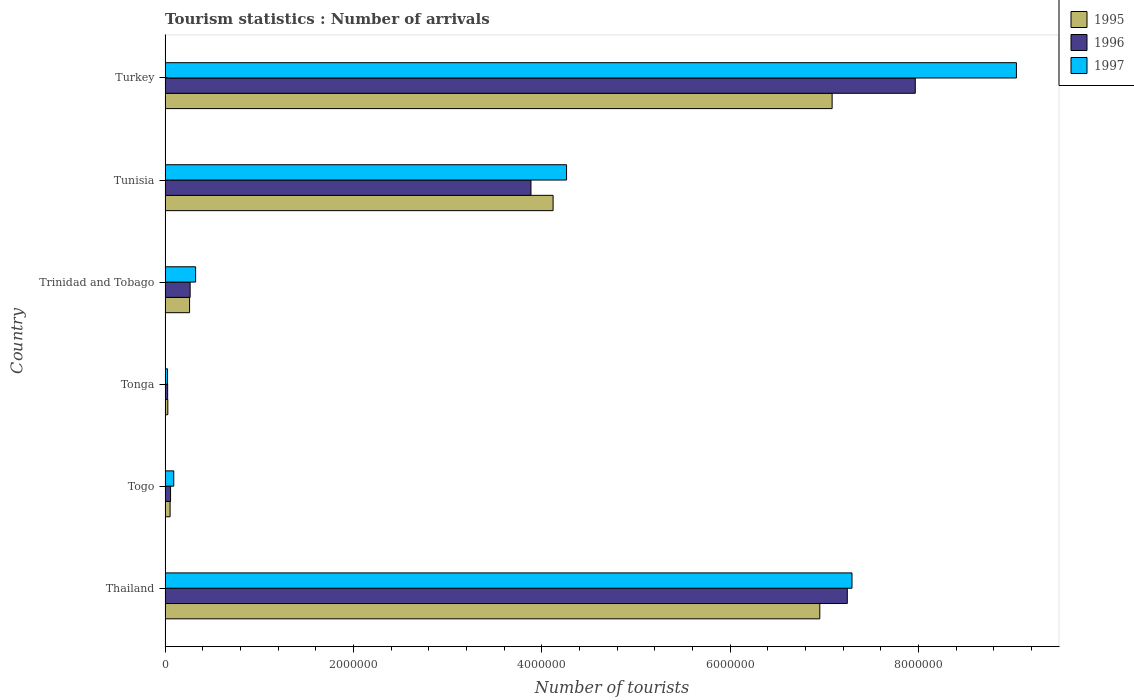Are the number of bars on each tick of the Y-axis equal?
Offer a terse response. Yes. What is the label of the 4th group of bars from the top?
Your answer should be compact. Tonga. What is the number of tourist arrivals in 1995 in Tunisia?
Make the answer very short. 4.12e+06. Across all countries, what is the maximum number of tourist arrivals in 1997?
Your answer should be compact. 9.04e+06. Across all countries, what is the minimum number of tourist arrivals in 1997?
Offer a very short reply. 2.60e+04. In which country was the number of tourist arrivals in 1997 maximum?
Provide a succinct answer. Turkey. In which country was the number of tourist arrivals in 1995 minimum?
Your response must be concise. Tonga. What is the total number of tourist arrivals in 1995 in the graph?
Offer a very short reply. 1.85e+07. What is the difference between the number of tourist arrivals in 1996 in Togo and that in Tonga?
Offer a very short reply. 3.10e+04. What is the difference between the number of tourist arrivals in 1995 in Tunisia and the number of tourist arrivals in 1996 in Trinidad and Tobago?
Your answer should be compact. 3.85e+06. What is the average number of tourist arrivals in 1997 per country?
Provide a short and direct response. 3.51e+06. What is the difference between the number of tourist arrivals in 1996 and number of tourist arrivals in 1995 in Trinidad and Tobago?
Offer a terse response. 6000. What is the ratio of the number of tourist arrivals in 1996 in Tonga to that in Trinidad and Tobago?
Make the answer very short. 0.1. Is the number of tourist arrivals in 1997 in Trinidad and Tobago less than that in Turkey?
Offer a very short reply. Yes. Is the difference between the number of tourist arrivals in 1996 in Thailand and Turkey greater than the difference between the number of tourist arrivals in 1995 in Thailand and Turkey?
Offer a terse response. No. What is the difference between the highest and the second highest number of tourist arrivals in 1995?
Your answer should be very brief. 1.31e+05. What is the difference between the highest and the lowest number of tourist arrivals in 1995?
Offer a very short reply. 7.05e+06. What does the 2nd bar from the top in Thailand represents?
Make the answer very short. 1996. Are all the bars in the graph horizontal?
Offer a terse response. Yes. How many countries are there in the graph?
Provide a short and direct response. 6. What is the difference between two consecutive major ticks on the X-axis?
Ensure brevity in your answer.  2.00e+06. Does the graph contain grids?
Your answer should be compact. No. What is the title of the graph?
Make the answer very short. Tourism statistics : Number of arrivals. Does "1965" appear as one of the legend labels in the graph?
Give a very brief answer. No. What is the label or title of the X-axis?
Offer a very short reply. Number of tourists. What is the Number of tourists in 1995 in Thailand?
Ensure brevity in your answer.  6.95e+06. What is the Number of tourists in 1996 in Thailand?
Keep it short and to the point. 7.24e+06. What is the Number of tourists in 1997 in Thailand?
Offer a terse response. 7.29e+06. What is the Number of tourists in 1995 in Togo?
Your answer should be very brief. 5.30e+04. What is the Number of tourists of 1996 in Togo?
Keep it short and to the point. 5.80e+04. What is the Number of tourists of 1997 in Togo?
Offer a very short reply. 9.20e+04. What is the Number of tourists in 1995 in Tonga?
Your answer should be very brief. 2.90e+04. What is the Number of tourists in 1996 in Tonga?
Provide a short and direct response. 2.70e+04. What is the Number of tourists of 1997 in Tonga?
Your response must be concise. 2.60e+04. What is the Number of tourists of 1996 in Trinidad and Tobago?
Provide a short and direct response. 2.66e+05. What is the Number of tourists of 1997 in Trinidad and Tobago?
Your response must be concise. 3.24e+05. What is the Number of tourists of 1995 in Tunisia?
Provide a short and direct response. 4.12e+06. What is the Number of tourists in 1996 in Tunisia?
Provide a short and direct response. 3.88e+06. What is the Number of tourists of 1997 in Tunisia?
Ensure brevity in your answer.  4.26e+06. What is the Number of tourists of 1995 in Turkey?
Ensure brevity in your answer.  7.08e+06. What is the Number of tourists in 1996 in Turkey?
Make the answer very short. 7.97e+06. What is the Number of tourists in 1997 in Turkey?
Offer a very short reply. 9.04e+06. Across all countries, what is the maximum Number of tourists in 1995?
Provide a short and direct response. 7.08e+06. Across all countries, what is the maximum Number of tourists in 1996?
Give a very brief answer. 7.97e+06. Across all countries, what is the maximum Number of tourists in 1997?
Provide a short and direct response. 9.04e+06. Across all countries, what is the minimum Number of tourists in 1995?
Your answer should be very brief. 2.90e+04. Across all countries, what is the minimum Number of tourists in 1996?
Your answer should be very brief. 2.70e+04. Across all countries, what is the minimum Number of tourists of 1997?
Offer a very short reply. 2.60e+04. What is the total Number of tourists in 1995 in the graph?
Keep it short and to the point. 1.85e+07. What is the total Number of tourists of 1996 in the graph?
Make the answer very short. 1.94e+07. What is the total Number of tourists of 1997 in the graph?
Keep it short and to the point. 2.10e+07. What is the difference between the Number of tourists of 1995 in Thailand and that in Togo?
Make the answer very short. 6.90e+06. What is the difference between the Number of tourists in 1996 in Thailand and that in Togo?
Offer a terse response. 7.19e+06. What is the difference between the Number of tourists of 1997 in Thailand and that in Togo?
Your answer should be compact. 7.20e+06. What is the difference between the Number of tourists in 1995 in Thailand and that in Tonga?
Offer a very short reply. 6.92e+06. What is the difference between the Number of tourists of 1996 in Thailand and that in Tonga?
Your answer should be very brief. 7.22e+06. What is the difference between the Number of tourists in 1997 in Thailand and that in Tonga?
Provide a short and direct response. 7.27e+06. What is the difference between the Number of tourists in 1995 in Thailand and that in Trinidad and Tobago?
Ensure brevity in your answer.  6.69e+06. What is the difference between the Number of tourists of 1996 in Thailand and that in Trinidad and Tobago?
Provide a short and direct response. 6.98e+06. What is the difference between the Number of tourists of 1997 in Thailand and that in Trinidad and Tobago?
Offer a terse response. 6.97e+06. What is the difference between the Number of tourists of 1995 in Thailand and that in Tunisia?
Offer a terse response. 2.83e+06. What is the difference between the Number of tourists in 1996 in Thailand and that in Tunisia?
Provide a succinct answer. 3.36e+06. What is the difference between the Number of tourists in 1997 in Thailand and that in Tunisia?
Provide a succinct answer. 3.03e+06. What is the difference between the Number of tourists of 1995 in Thailand and that in Turkey?
Ensure brevity in your answer.  -1.31e+05. What is the difference between the Number of tourists of 1996 in Thailand and that in Turkey?
Give a very brief answer. -7.22e+05. What is the difference between the Number of tourists of 1997 in Thailand and that in Turkey?
Offer a very short reply. -1.75e+06. What is the difference between the Number of tourists in 1995 in Togo and that in Tonga?
Offer a very short reply. 2.40e+04. What is the difference between the Number of tourists of 1996 in Togo and that in Tonga?
Keep it short and to the point. 3.10e+04. What is the difference between the Number of tourists in 1997 in Togo and that in Tonga?
Offer a very short reply. 6.60e+04. What is the difference between the Number of tourists of 1995 in Togo and that in Trinidad and Tobago?
Your response must be concise. -2.07e+05. What is the difference between the Number of tourists of 1996 in Togo and that in Trinidad and Tobago?
Your response must be concise. -2.08e+05. What is the difference between the Number of tourists in 1997 in Togo and that in Trinidad and Tobago?
Ensure brevity in your answer.  -2.32e+05. What is the difference between the Number of tourists of 1995 in Togo and that in Tunisia?
Your response must be concise. -4.07e+06. What is the difference between the Number of tourists of 1996 in Togo and that in Tunisia?
Keep it short and to the point. -3.83e+06. What is the difference between the Number of tourists in 1997 in Togo and that in Tunisia?
Make the answer very short. -4.17e+06. What is the difference between the Number of tourists in 1995 in Togo and that in Turkey?
Your response must be concise. -7.03e+06. What is the difference between the Number of tourists in 1996 in Togo and that in Turkey?
Provide a short and direct response. -7.91e+06. What is the difference between the Number of tourists of 1997 in Togo and that in Turkey?
Provide a short and direct response. -8.95e+06. What is the difference between the Number of tourists of 1995 in Tonga and that in Trinidad and Tobago?
Keep it short and to the point. -2.31e+05. What is the difference between the Number of tourists of 1996 in Tonga and that in Trinidad and Tobago?
Offer a terse response. -2.39e+05. What is the difference between the Number of tourists in 1997 in Tonga and that in Trinidad and Tobago?
Keep it short and to the point. -2.98e+05. What is the difference between the Number of tourists of 1995 in Tonga and that in Tunisia?
Your response must be concise. -4.09e+06. What is the difference between the Number of tourists of 1996 in Tonga and that in Tunisia?
Make the answer very short. -3.86e+06. What is the difference between the Number of tourists of 1997 in Tonga and that in Tunisia?
Offer a terse response. -4.24e+06. What is the difference between the Number of tourists of 1995 in Tonga and that in Turkey?
Your answer should be very brief. -7.05e+06. What is the difference between the Number of tourists of 1996 in Tonga and that in Turkey?
Give a very brief answer. -7.94e+06. What is the difference between the Number of tourists of 1997 in Tonga and that in Turkey?
Give a very brief answer. -9.01e+06. What is the difference between the Number of tourists of 1995 in Trinidad and Tobago and that in Tunisia?
Provide a short and direct response. -3.86e+06. What is the difference between the Number of tourists in 1996 in Trinidad and Tobago and that in Tunisia?
Provide a succinct answer. -3.62e+06. What is the difference between the Number of tourists of 1997 in Trinidad and Tobago and that in Tunisia?
Give a very brief answer. -3.94e+06. What is the difference between the Number of tourists of 1995 in Trinidad and Tobago and that in Turkey?
Your answer should be very brief. -6.82e+06. What is the difference between the Number of tourists in 1996 in Trinidad and Tobago and that in Turkey?
Your response must be concise. -7.70e+06. What is the difference between the Number of tourists of 1997 in Trinidad and Tobago and that in Turkey?
Give a very brief answer. -8.72e+06. What is the difference between the Number of tourists in 1995 in Tunisia and that in Turkey?
Your answer should be compact. -2.96e+06. What is the difference between the Number of tourists in 1996 in Tunisia and that in Turkey?
Make the answer very short. -4.08e+06. What is the difference between the Number of tourists of 1997 in Tunisia and that in Turkey?
Give a very brief answer. -4.78e+06. What is the difference between the Number of tourists of 1995 in Thailand and the Number of tourists of 1996 in Togo?
Give a very brief answer. 6.89e+06. What is the difference between the Number of tourists in 1995 in Thailand and the Number of tourists in 1997 in Togo?
Your answer should be very brief. 6.86e+06. What is the difference between the Number of tourists in 1996 in Thailand and the Number of tourists in 1997 in Togo?
Ensure brevity in your answer.  7.15e+06. What is the difference between the Number of tourists of 1995 in Thailand and the Number of tourists of 1996 in Tonga?
Your answer should be compact. 6.92e+06. What is the difference between the Number of tourists of 1995 in Thailand and the Number of tourists of 1997 in Tonga?
Your answer should be very brief. 6.93e+06. What is the difference between the Number of tourists of 1996 in Thailand and the Number of tourists of 1997 in Tonga?
Your response must be concise. 7.22e+06. What is the difference between the Number of tourists in 1995 in Thailand and the Number of tourists in 1996 in Trinidad and Tobago?
Ensure brevity in your answer.  6.69e+06. What is the difference between the Number of tourists in 1995 in Thailand and the Number of tourists in 1997 in Trinidad and Tobago?
Provide a short and direct response. 6.63e+06. What is the difference between the Number of tourists of 1996 in Thailand and the Number of tourists of 1997 in Trinidad and Tobago?
Make the answer very short. 6.92e+06. What is the difference between the Number of tourists of 1995 in Thailand and the Number of tourists of 1996 in Tunisia?
Your answer should be very brief. 3.07e+06. What is the difference between the Number of tourists of 1995 in Thailand and the Number of tourists of 1997 in Tunisia?
Give a very brief answer. 2.69e+06. What is the difference between the Number of tourists in 1996 in Thailand and the Number of tourists in 1997 in Tunisia?
Offer a very short reply. 2.98e+06. What is the difference between the Number of tourists in 1995 in Thailand and the Number of tourists in 1996 in Turkey?
Give a very brief answer. -1.01e+06. What is the difference between the Number of tourists of 1995 in Thailand and the Number of tourists of 1997 in Turkey?
Your answer should be very brief. -2.09e+06. What is the difference between the Number of tourists in 1996 in Thailand and the Number of tourists in 1997 in Turkey?
Offer a very short reply. -1.80e+06. What is the difference between the Number of tourists in 1995 in Togo and the Number of tourists in 1996 in Tonga?
Your answer should be very brief. 2.60e+04. What is the difference between the Number of tourists of 1995 in Togo and the Number of tourists of 1997 in Tonga?
Keep it short and to the point. 2.70e+04. What is the difference between the Number of tourists of 1996 in Togo and the Number of tourists of 1997 in Tonga?
Your response must be concise. 3.20e+04. What is the difference between the Number of tourists of 1995 in Togo and the Number of tourists of 1996 in Trinidad and Tobago?
Give a very brief answer. -2.13e+05. What is the difference between the Number of tourists of 1995 in Togo and the Number of tourists of 1997 in Trinidad and Tobago?
Keep it short and to the point. -2.71e+05. What is the difference between the Number of tourists of 1996 in Togo and the Number of tourists of 1997 in Trinidad and Tobago?
Your answer should be very brief. -2.66e+05. What is the difference between the Number of tourists in 1995 in Togo and the Number of tourists in 1996 in Tunisia?
Your response must be concise. -3.83e+06. What is the difference between the Number of tourists of 1995 in Togo and the Number of tourists of 1997 in Tunisia?
Give a very brief answer. -4.21e+06. What is the difference between the Number of tourists of 1996 in Togo and the Number of tourists of 1997 in Tunisia?
Provide a succinct answer. -4.20e+06. What is the difference between the Number of tourists in 1995 in Togo and the Number of tourists in 1996 in Turkey?
Offer a very short reply. -7.91e+06. What is the difference between the Number of tourists in 1995 in Togo and the Number of tourists in 1997 in Turkey?
Your answer should be compact. -8.99e+06. What is the difference between the Number of tourists in 1996 in Togo and the Number of tourists in 1997 in Turkey?
Offer a terse response. -8.98e+06. What is the difference between the Number of tourists in 1995 in Tonga and the Number of tourists in 1996 in Trinidad and Tobago?
Your response must be concise. -2.37e+05. What is the difference between the Number of tourists in 1995 in Tonga and the Number of tourists in 1997 in Trinidad and Tobago?
Your response must be concise. -2.95e+05. What is the difference between the Number of tourists of 1996 in Tonga and the Number of tourists of 1997 in Trinidad and Tobago?
Give a very brief answer. -2.97e+05. What is the difference between the Number of tourists of 1995 in Tonga and the Number of tourists of 1996 in Tunisia?
Your answer should be very brief. -3.86e+06. What is the difference between the Number of tourists in 1995 in Tonga and the Number of tourists in 1997 in Tunisia?
Keep it short and to the point. -4.23e+06. What is the difference between the Number of tourists in 1996 in Tonga and the Number of tourists in 1997 in Tunisia?
Make the answer very short. -4.24e+06. What is the difference between the Number of tourists of 1995 in Tonga and the Number of tourists of 1996 in Turkey?
Your response must be concise. -7.94e+06. What is the difference between the Number of tourists in 1995 in Tonga and the Number of tourists in 1997 in Turkey?
Give a very brief answer. -9.01e+06. What is the difference between the Number of tourists of 1996 in Tonga and the Number of tourists of 1997 in Turkey?
Keep it short and to the point. -9.01e+06. What is the difference between the Number of tourists in 1995 in Trinidad and Tobago and the Number of tourists in 1996 in Tunisia?
Provide a short and direct response. -3.62e+06. What is the difference between the Number of tourists of 1995 in Trinidad and Tobago and the Number of tourists of 1997 in Tunisia?
Keep it short and to the point. -4.00e+06. What is the difference between the Number of tourists of 1996 in Trinidad and Tobago and the Number of tourists of 1997 in Tunisia?
Provide a succinct answer. -4.00e+06. What is the difference between the Number of tourists of 1995 in Trinidad and Tobago and the Number of tourists of 1996 in Turkey?
Give a very brief answer. -7.71e+06. What is the difference between the Number of tourists in 1995 in Trinidad and Tobago and the Number of tourists in 1997 in Turkey?
Provide a short and direct response. -8.78e+06. What is the difference between the Number of tourists of 1996 in Trinidad and Tobago and the Number of tourists of 1997 in Turkey?
Ensure brevity in your answer.  -8.77e+06. What is the difference between the Number of tourists in 1995 in Tunisia and the Number of tourists in 1996 in Turkey?
Your answer should be compact. -3.85e+06. What is the difference between the Number of tourists in 1995 in Tunisia and the Number of tourists in 1997 in Turkey?
Provide a succinct answer. -4.92e+06. What is the difference between the Number of tourists in 1996 in Tunisia and the Number of tourists in 1997 in Turkey?
Give a very brief answer. -5.16e+06. What is the average Number of tourists in 1995 per country?
Ensure brevity in your answer.  3.08e+06. What is the average Number of tourists of 1996 per country?
Keep it short and to the point. 3.24e+06. What is the average Number of tourists of 1997 per country?
Keep it short and to the point. 3.51e+06. What is the difference between the Number of tourists of 1995 and Number of tourists of 1996 in Thailand?
Your response must be concise. -2.92e+05. What is the difference between the Number of tourists of 1995 and Number of tourists of 1997 in Thailand?
Make the answer very short. -3.42e+05. What is the difference between the Number of tourists of 1995 and Number of tourists of 1996 in Togo?
Your answer should be very brief. -5000. What is the difference between the Number of tourists of 1995 and Number of tourists of 1997 in Togo?
Your response must be concise. -3.90e+04. What is the difference between the Number of tourists of 1996 and Number of tourists of 1997 in Togo?
Offer a very short reply. -3.40e+04. What is the difference between the Number of tourists of 1995 and Number of tourists of 1996 in Tonga?
Give a very brief answer. 2000. What is the difference between the Number of tourists in 1995 and Number of tourists in 1997 in Tonga?
Keep it short and to the point. 3000. What is the difference between the Number of tourists of 1995 and Number of tourists of 1996 in Trinidad and Tobago?
Provide a short and direct response. -6000. What is the difference between the Number of tourists of 1995 and Number of tourists of 1997 in Trinidad and Tobago?
Give a very brief answer. -6.40e+04. What is the difference between the Number of tourists of 1996 and Number of tourists of 1997 in Trinidad and Tobago?
Offer a very short reply. -5.80e+04. What is the difference between the Number of tourists of 1995 and Number of tourists of 1996 in Tunisia?
Ensure brevity in your answer.  2.35e+05. What is the difference between the Number of tourists of 1995 and Number of tourists of 1997 in Tunisia?
Offer a very short reply. -1.43e+05. What is the difference between the Number of tourists in 1996 and Number of tourists in 1997 in Tunisia?
Make the answer very short. -3.78e+05. What is the difference between the Number of tourists in 1995 and Number of tourists in 1996 in Turkey?
Offer a terse response. -8.83e+05. What is the difference between the Number of tourists of 1995 and Number of tourists of 1997 in Turkey?
Ensure brevity in your answer.  -1.96e+06. What is the difference between the Number of tourists in 1996 and Number of tourists in 1997 in Turkey?
Provide a short and direct response. -1.07e+06. What is the ratio of the Number of tourists in 1995 in Thailand to that in Togo?
Make the answer very short. 131.17. What is the ratio of the Number of tourists of 1996 in Thailand to that in Togo?
Provide a short and direct response. 124.9. What is the ratio of the Number of tourists of 1997 in Thailand to that in Togo?
Provide a short and direct response. 79.28. What is the ratio of the Number of tourists of 1995 in Thailand to that in Tonga?
Provide a short and direct response. 239.72. What is the ratio of the Number of tourists in 1996 in Thailand to that in Tonga?
Make the answer very short. 268.3. What is the ratio of the Number of tourists of 1997 in Thailand to that in Tonga?
Ensure brevity in your answer.  280.54. What is the ratio of the Number of tourists of 1995 in Thailand to that in Trinidad and Tobago?
Offer a terse response. 26.74. What is the ratio of the Number of tourists in 1996 in Thailand to that in Trinidad and Tobago?
Your response must be concise. 27.23. What is the ratio of the Number of tourists in 1997 in Thailand to that in Trinidad and Tobago?
Offer a very short reply. 22.51. What is the ratio of the Number of tourists of 1995 in Thailand to that in Tunisia?
Give a very brief answer. 1.69. What is the ratio of the Number of tourists of 1996 in Thailand to that in Tunisia?
Keep it short and to the point. 1.86. What is the ratio of the Number of tourists of 1997 in Thailand to that in Tunisia?
Offer a very short reply. 1.71. What is the ratio of the Number of tourists of 1995 in Thailand to that in Turkey?
Keep it short and to the point. 0.98. What is the ratio of the Number of tourists of 1996 in Thailand to that in Turkey?
Ensure brevity in your answer.  0.91. What is the ratio of the Number of tourists of 1997 in Thailand to that in Turkey?
Ensure brevity in your answer.  0.81. What is the ratio of the Number of tourists in 1995 in Togo to that in Tonga?
Your answer should be very brief. 1.83. What is the ratio of the Number of tourists of 1996 in Togo to that in Tonga?
Keep it short and to the point. 2.15. What is the ratio of the Number of tourists of 1997 in Togo to that in Tonga?
Your answer should be compact. 3.54. What is the ratio of the Number of tourists in 1995 in Togo to that in Trinidad and Tobago?
Your answer should be compact. 0.2. What is the ratio of the Number of tourists in 1996 in Togo to that in Trinidad and Tobago?
Give a very brief answer. 0.22. What is the ratio of the Number of tourists in 1997 in Togo to that in Trinidad and Tobago?
Your answer should be compact. 0.28. What is the ratio of the Number of tourists of 1995 in Togo to that in Tunisia?
Provide a succinct answer. 0.01. What is the ratio of the Number of tourists in 1996 in Togo to that in Tunisia?
Your response must be concise. 0.01. What is the ratio of the Number of tourists in 1997 in Togo to that in Tunisia?
Provide a succinct answer. 0.02. What is the ratio of the Number of tourists of 1995 in Togo to that in Turkey?
Provide a short and direct response. 0.01. What is the ratio of the Number of tourists of 1996 in Togo to that in Turkey?
Ensure brevity in your answer.  0.01. What is the ratio of the Number of tourists of 1997 in Togo to that in Turkey?
Make the answer very short. 0.01. What is the ratio of the Number of tourists in 1995 in Tonga to that in Trinidad and Tobago?
Your answer should be very brief. 0.11. What is the ratio of the Number of tourists of 1996 in Tonga to that in Trinidad and Tobago?
Provide a succinct answer. 0.1. What is the ratio of the Number of tourists of 1997 in Tonga to that in Trinidad and Tobago?
Your answer should be compact. 0.08. What is the ratio of the Number of tourists of 1995 in Tonga to that in Tunisia?
Offer a terse response. 0.01. What is the ratio of the Number of tourists of 1996 in Tonga to that in Tunisia?
Offer a very short reply. 0.01. What is the ratio of the Number of tourists in 1997 in Tonga to that in Tunisia?
Offer a terse response. 0.01. What is the ratio of the Number of tourists of 1995 in Tonga to that in Turkey?
Provide a short and direct response. 0. What is the ratio of the Number of tourists in 1996 in Tonga to that in Turkey?
Make the answer very short. 0. What is the ratio of the Number of tourists of 1997 in Tonga to that in Turkey?
Provide a short and direct response. 0. What is the ratio of the Number of tourists in 1995 in Trinidad and Tobago to that in Tunisia?
Give a very brief answer. 0.06. What is the ratio of the Number of tourists of 1996 in Trinidad and Tobago to that in Tunisia?
Your answer should be compact. 0.07. What is the ratio of the Number of tourists in 1997 in Trinidad and Tobago to that in Tunisia?
Offer a very short reply. 0.08. What is the ratio of the Number of tourists of 1995 in Trinidad and Tobago to that in Turkey?
Your answer should be compact. 0.04. What is the ratio of the Number of tourists of 1996 in Trinidad and Tobago to that in Turkey?
Your answer should be very brief. 0.03. What is the ratio of the Number of tourists in 1997 in Trinidad and Tobago to that in Turkey?
Ensure brevity in your answer.  0.04. What is the ratio of the Number of tourists in 1995 in Tunisia to that in Turkey?
Provide a succinct answer. 0.58. What is the ratio of the Number of tourists of 1996 in Tunisia to that in Turkey?
Your answer should be compact. 0.49. What is the ratio of the Number of tourists of 1997 in Tunisia to that in Turkey?
Your answer should be very brief. 0.47. What is the difference between the highest and the second highest Number of tourists of 1995?
Make the answer very short. 1.31e+05. What is the difference between the highest and the second highest Number of tourists in 1996?
Your response must be concise. 7.22e+05. What is the difference between the highest and the second highest Number of tourists in 1997?
Ensure brevity in your answer.  1.75e+06. What is the difference between the highest and the lowest Number of tourists in 1995?
Your answer should be very brief. 7.05e+06. What is the difference between the highest and the lowest Number of tourists in 1996?
Your answer should be compact. 7.94e+06. What is the difference between the highest and the lowest Number of tourists of 1997?
Keep it short and to the point. 9.01e+06. 